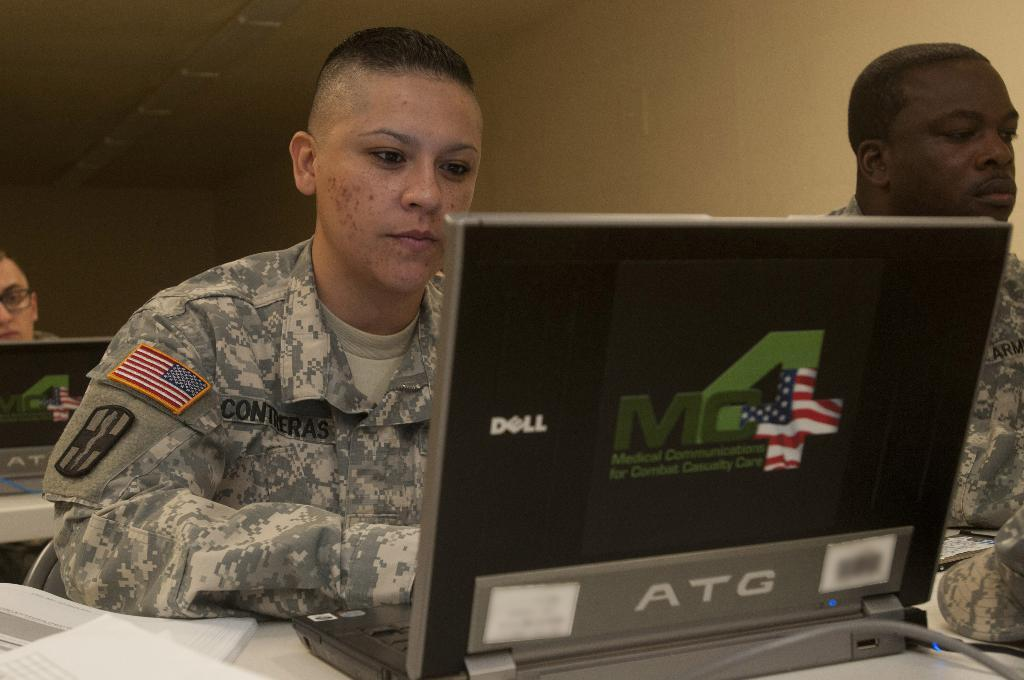How many people are in the image? There are three persons in the image. What is the position of one of the persons? One person is sitting on a chair. What items can be seen on the table? There are books, a laptop, and a cap on the table. What type of street is visible in the image? There is no street visible in the image; it appears to be an indoor setting with a table and chairs. 